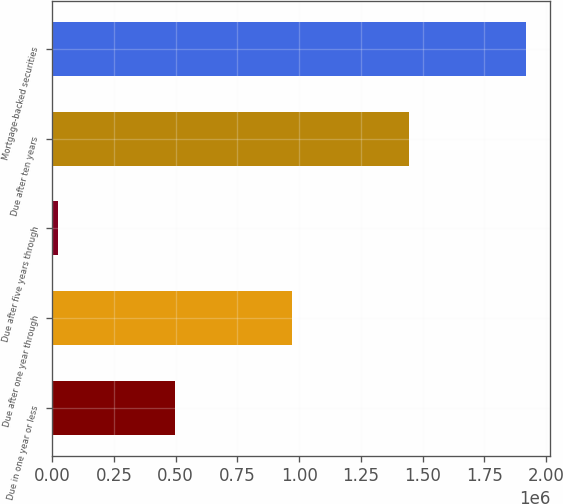<chart> <loc_0><loc_0><loc_500><loc_500><bar_chart><fcel>Due in one year or less<fcel>Due after one year through<fcel>Due after five years through<fcel>Due after ten years<fcel>Mortgage-backed securities<nl><fcel>498613<fcel>972568<fcel>24658<fcel>1.44652e+06<fcel>1.92048e+06<nl></chart> 